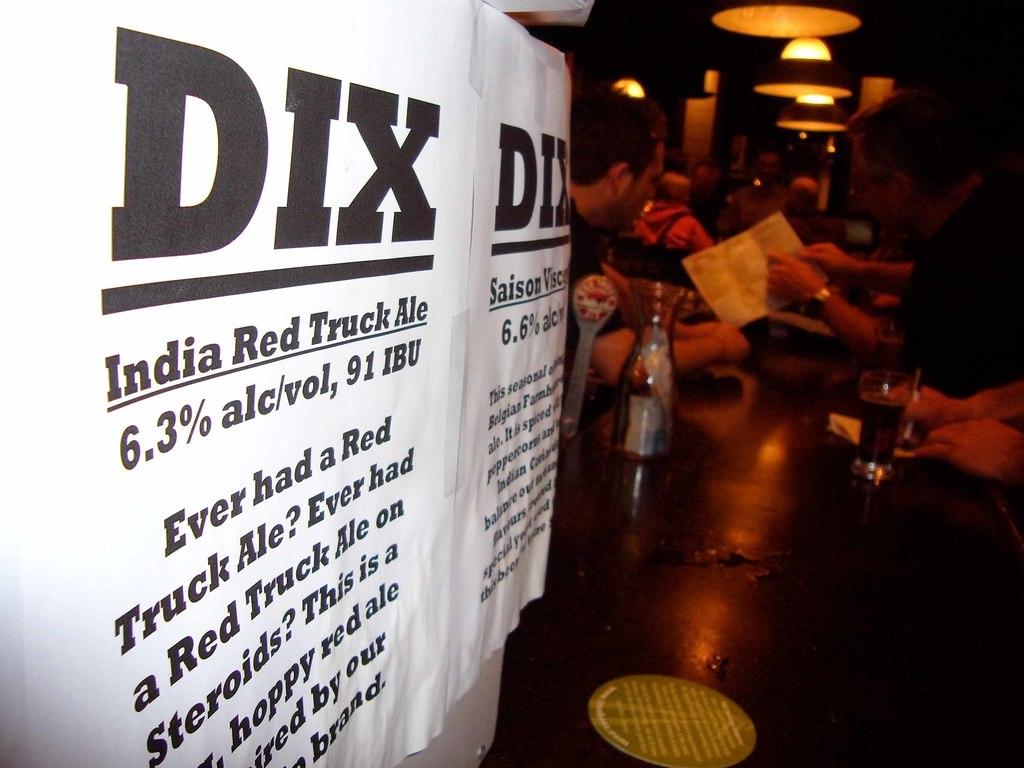What alcohol percentage is in dix ale?
Make the answer very short. 6.3%. What are the four words under the word "dix"?
Offer a terse response. India red truck ale. 